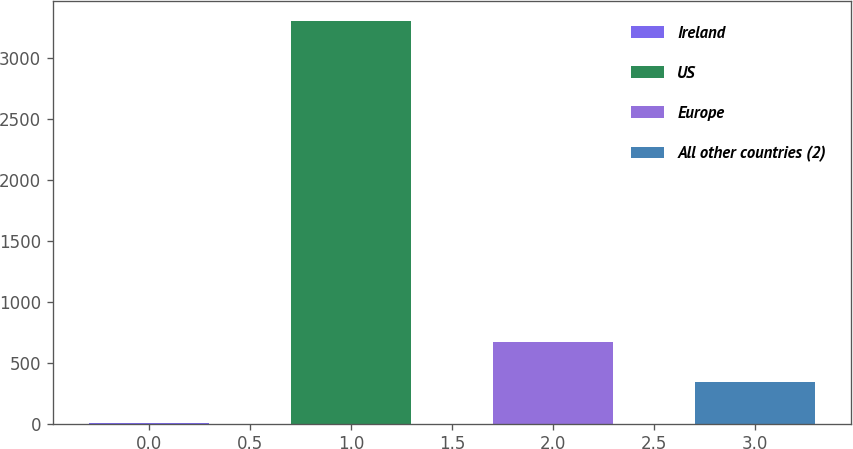Convert chart. <chart><loc_0><loc_0><loc_500><loc_500><bar_chart><fcel>Ireland<fcel>US<fcel>Europe<fcel>All other countries (2)<nl><fcel>7.2<fcel>3303.2<fcel>669.9<fcel>340.3<nl></chart> 